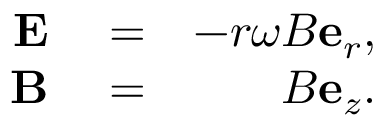Convert formula to latex. <formula><loc_0><loc_0><loc_500><loc_500>\begin{array} { r l r } { E } & = } & { - r \omega B e _ { r } , } \\ { B } & = } & { B e _ { z } . } \end{array}</formula> 